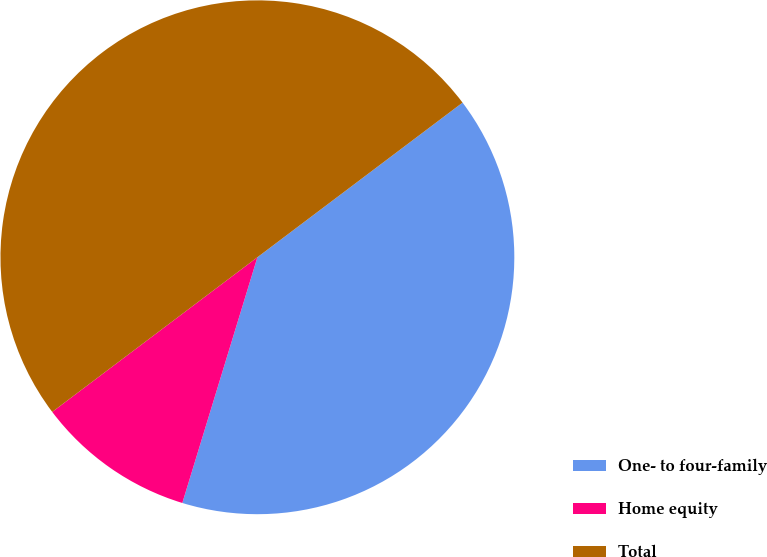<chart> <loc_0><loc_0><loc_500><loc_500><pie_chart><fcel>One- to four-family<fcel>Home equity<fcel>Total<nl><fcel>40.0%<fcel>10.0%<fcel>50.0%<nl></chart> 